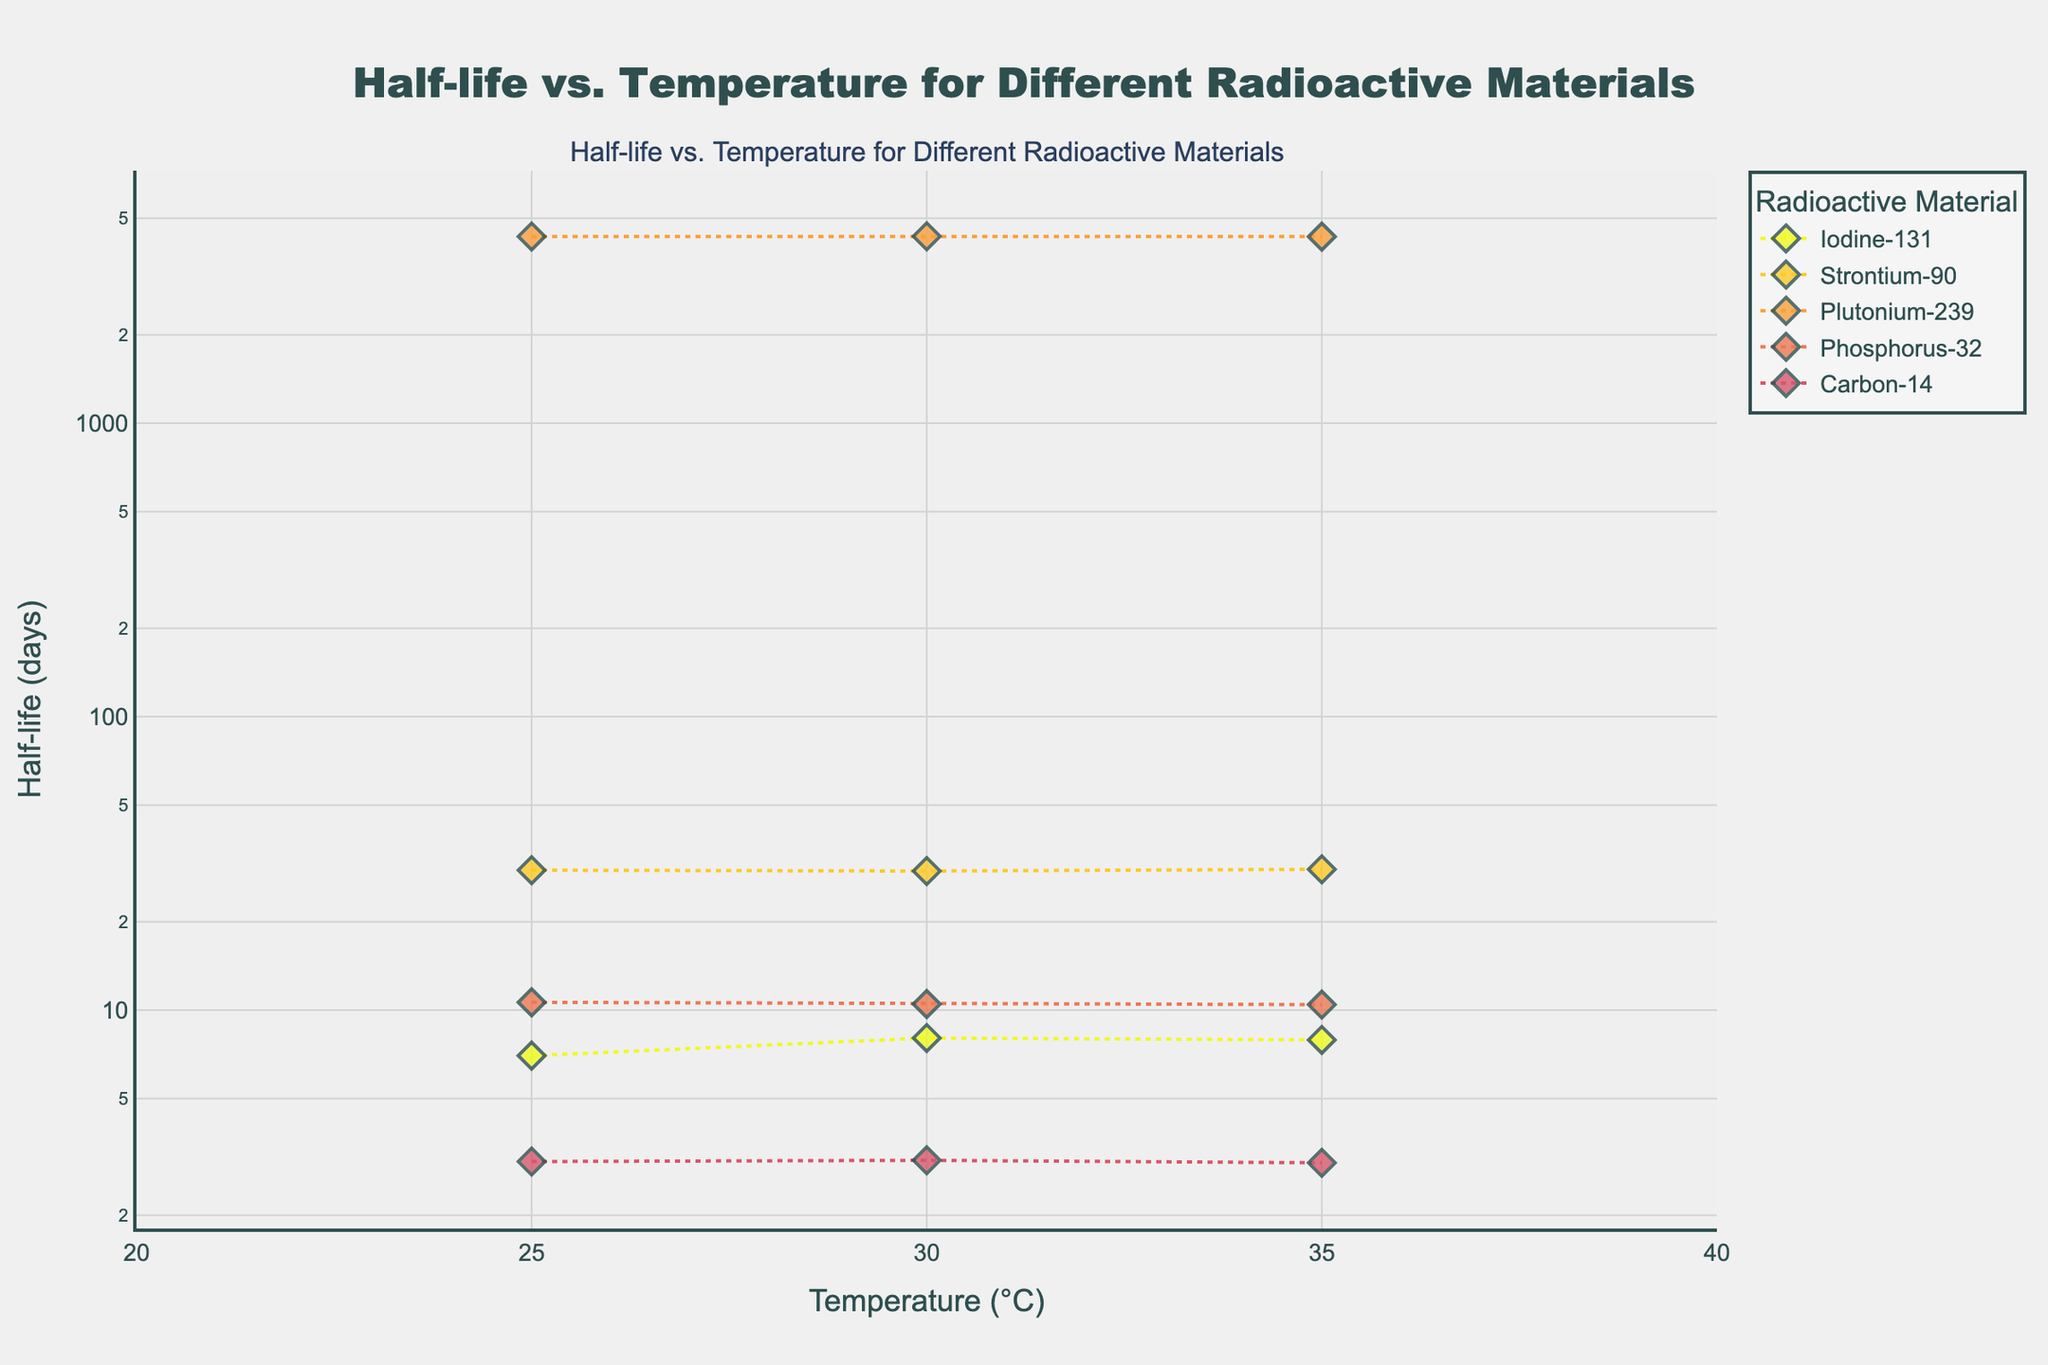What is the title of the plot? The title is located at the top center of the plot. To find it, look at the text in a larger font size and bold style.
Answer: Half-life vs. Temperature for Different Radioactive Materials What are the axes titles on the plot? The axes titles can be found next to the vertical (y-axis) and horizontal (x-axis) lines. The y-axis title reads "Half-life (days)" and the x-axis title reads "Temperature (°C)".
Answer: Temperature (°C), Half-life (days) Which material shows nearly constant half-life with varying temperature? By visual inspection, look for the material whose data points form a nearly horizontal line. This indicates very little change in half-life with temperature. Plutonium-239 shows nearly constant values around 4330 days.
Answer: Plutonium-239 What is the range of temperatures plotted on the x-axis? The temperature values appear on the x-axis. These values range from 25°C to 35°C, as indicated by the axis ticks.
Answer: 25°C to 35°C Which material has the shortest half-life in this plot? By examining the y-axis values for each material, look for the lowest y-axis value. Carbon-14 has the shortest half-life, around 3.02 to 3.08 days.
Answer: Carbon-14 Between Iodine-131 and Strontium-90, which material shows more variation in half-life with temperature? Compare the spread of y-axis values for Iodine-131 and Strontium-90. Iodine-131 ranges from 7 to 8.04 days, while Strontium-90 ranges from 29.8 to 30.2 days. Therefore, Iodine-131 shows more variation.
Answer: Iodine-131 What is the average half-life of Phosphorus-32 at the three different temperatures? Identify the three y-axis values for Phosphorus-32: 10.64, 10.5, and 10.45 days. Calculate the average: (10.64 + 10.5 + 10.45) / 3 = 10.53 days.
Answer: 10.53 days What trend, if any, is observed for Carbon-14's half-life as temperature increases? Examine the y-axis values for Carbon-14 as the temperature on the x-axis increases from 25°C to 35°C. The half-life slightly decreases, showing a downward trend.
Answer: Slight decrease Do any materials show an increase in half-life with an increase in temperature? Check if any material's y-axis values increase as the x-axis values (temperature) increase. None of the materials show a clear increase in half-life.
Answer: No How many different radioactive materials are displayed in the plot? Count the number of unique materials in the plot legend or by identifying distinct markers/colors on the plot. There are five different materials.
Answer: Five 